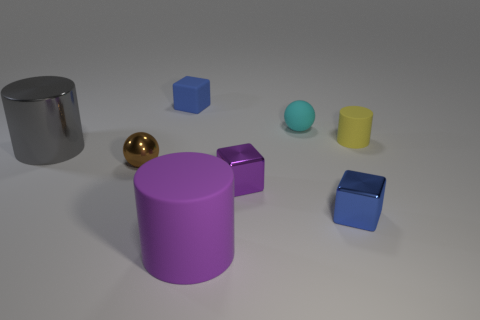Add 2 yellow matte cylinders. How many objects exist? 10 Subtract all balls. How many objects are left? 6 Subtract 1 blue cubes. How many objects are left? 7 Subtract all big brown shiny cubes. Subtract all matte things. How many objects are left? 4 Add 5 brown objects. How many brown objects are left? 6 Add 7 tiny cyan objects. How many tiny cyan objects exist? 8 